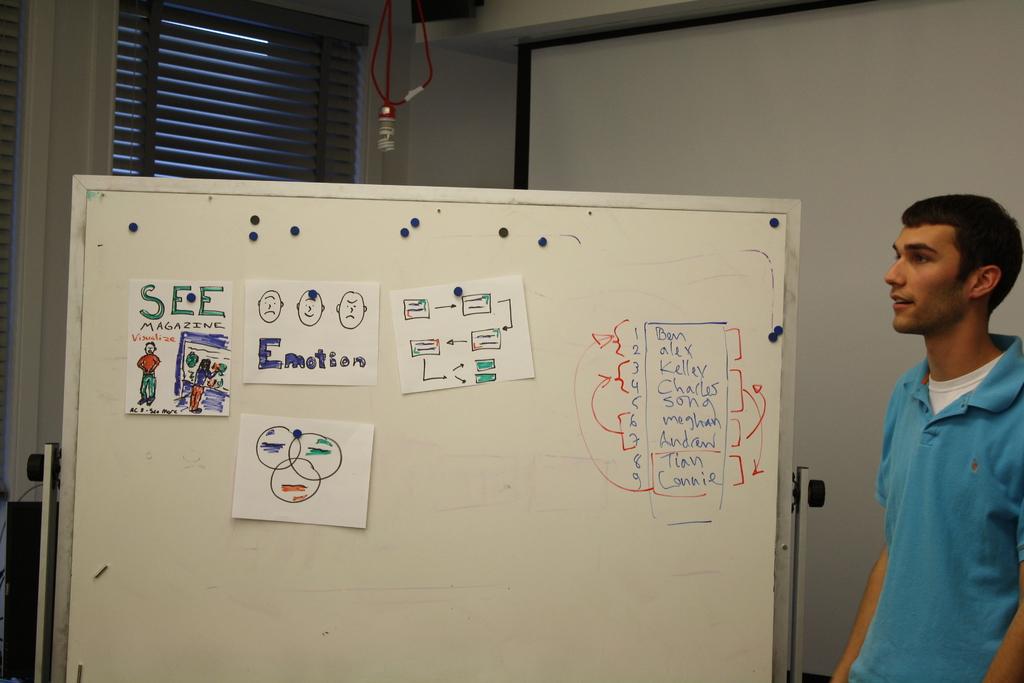Who is the third person on the list of people?
Your answer should be very brief. Kelley. What name is listed first on the right?
Offer a terse response. Ben. 